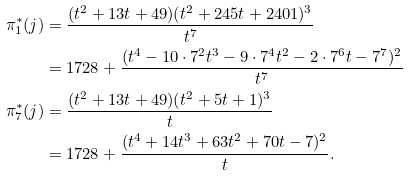Convert formula to latex. <formula><loc_0><loc_0><loc_500><loc_500>\pi _ { 1 } ^ { * } ( j ) & = \frac { ( t ^ { 2 } + 1 3 t + 4 9 ) ( t ^ { 2 } + 2 4 5 t + 2 4 0 1 ) ^ { 3 } } { t ^ { 7 } } \\ & = 1 7 2 8 + \frac { ( t ^ { 4 } - 1 0 \cdot 7 ^ { 2 } t ^ { 3 } - 9 \cdot 7 ^ { 4 } t ^ { 2 } - 2 \cdot 7 ^ { 6 } t - 7 ^ { 7 } ) ^ { 2 } } { t ^ { 7 } } \\ \pi _ { 7 } ^ { * } ( j ) & = \frac { ( t ^ { 2 } + 1 3 t + 4 9 ) ( t ^ { 2 } + 5 t + 1 ) ^ { 3 } } { t } \\ & = 1 7 2 8 + \frac { ( t ^ { 4 } + 1 4 t ^ { 3 } + 6 3 t ^ { 2 } + 7 0 t - 7 ) ^ { 2 } } { t } .</formula> 